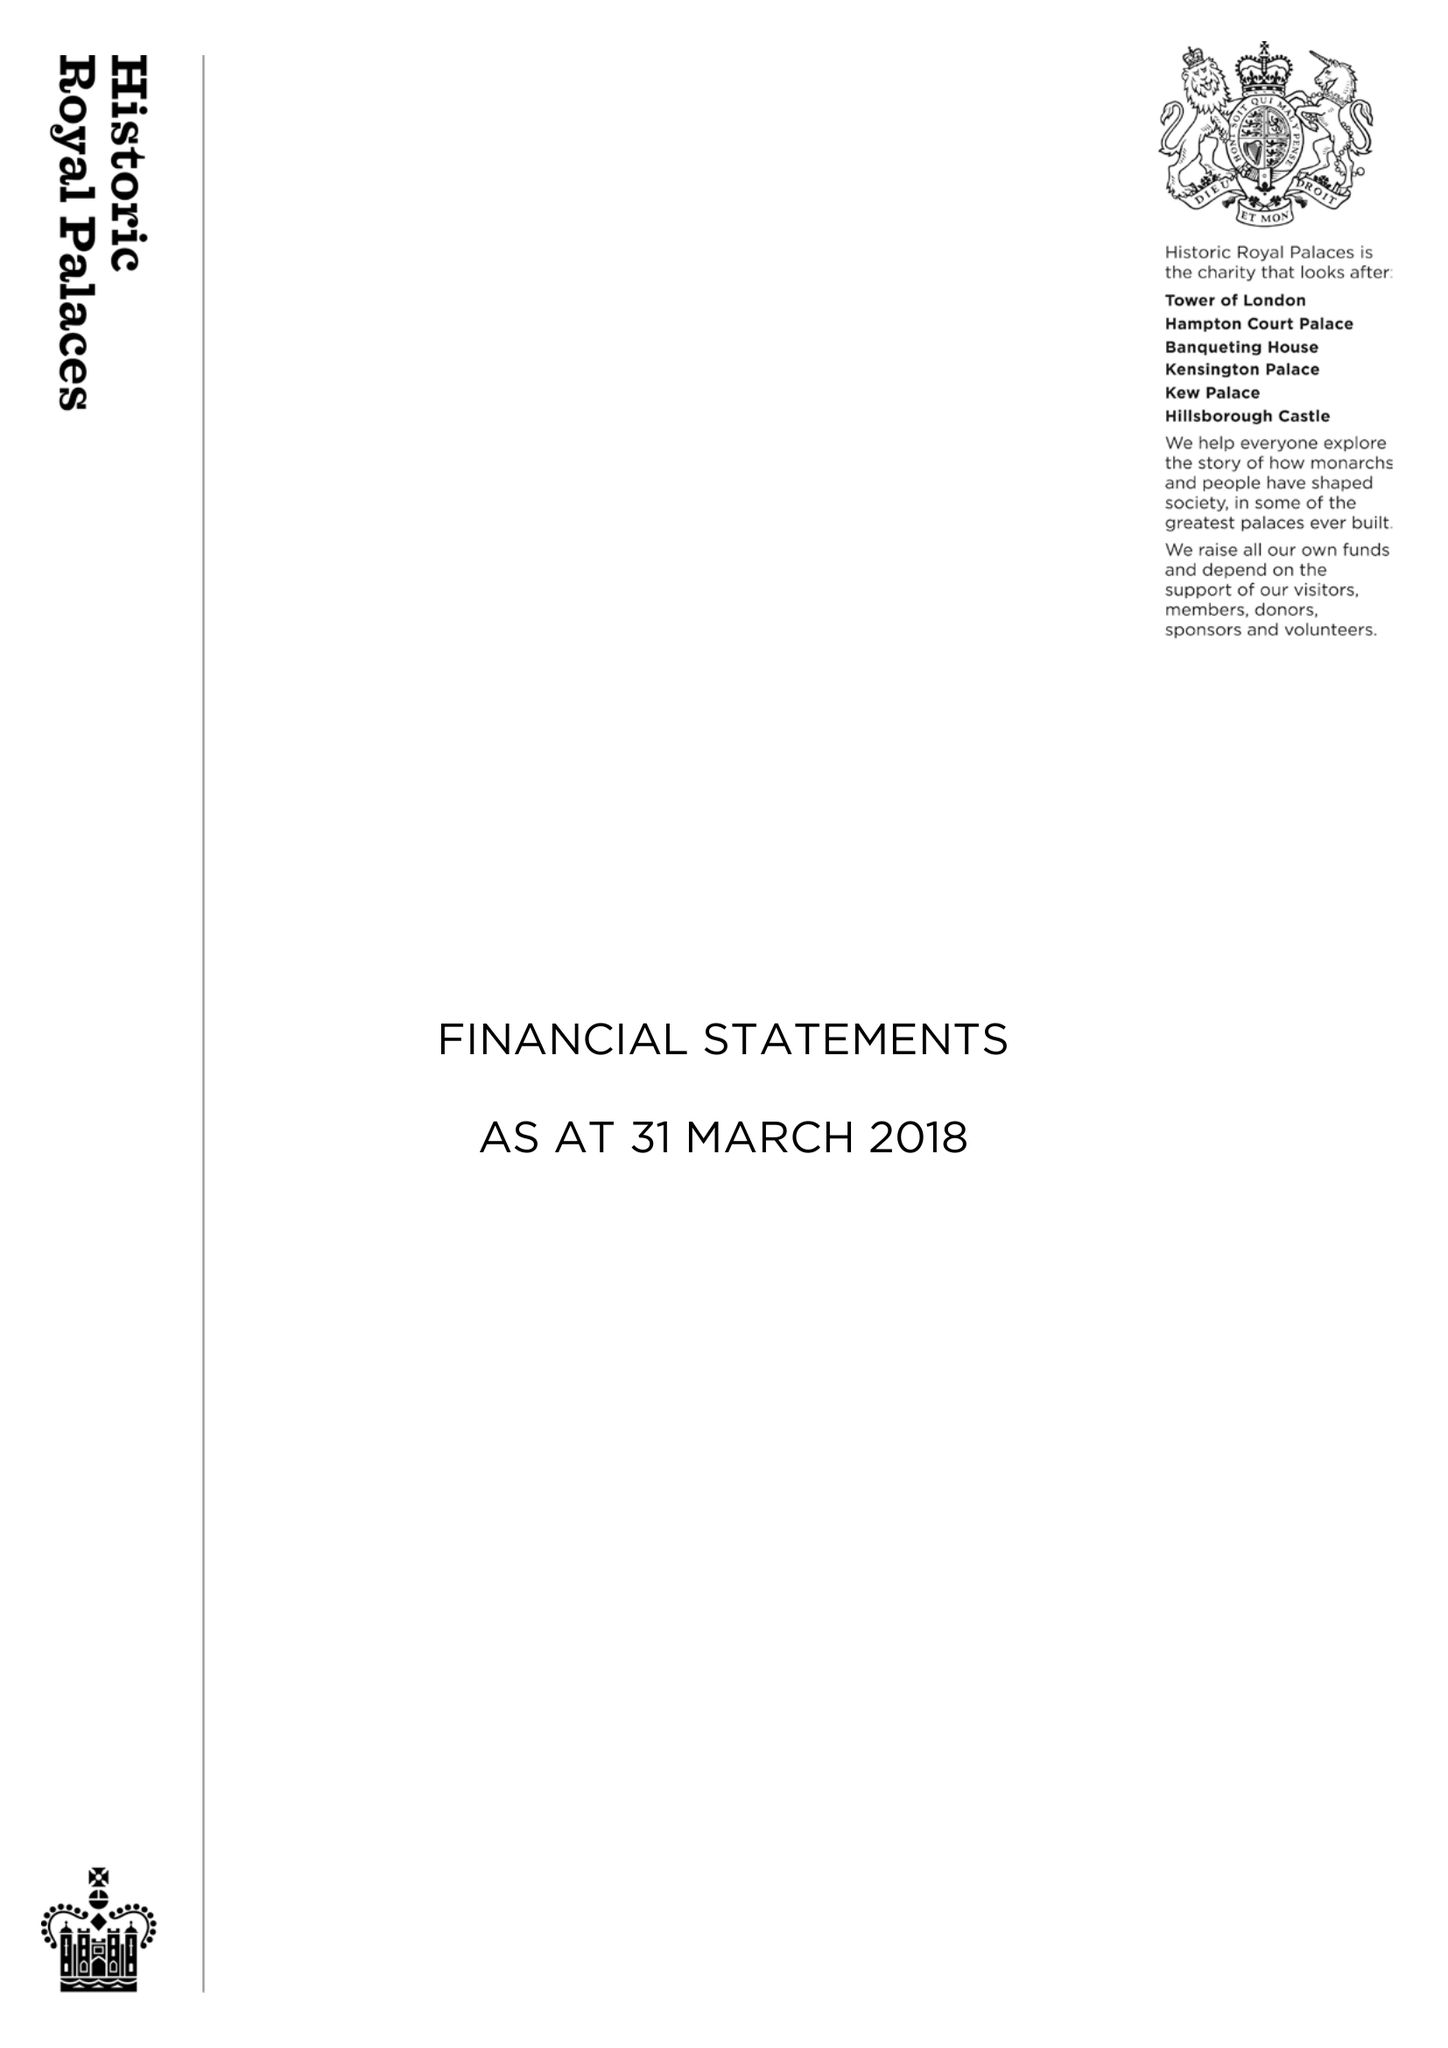What is the value for the spending_annually_in_british_pounds?
Answer the question using a single word or phrase. 95102929.00 